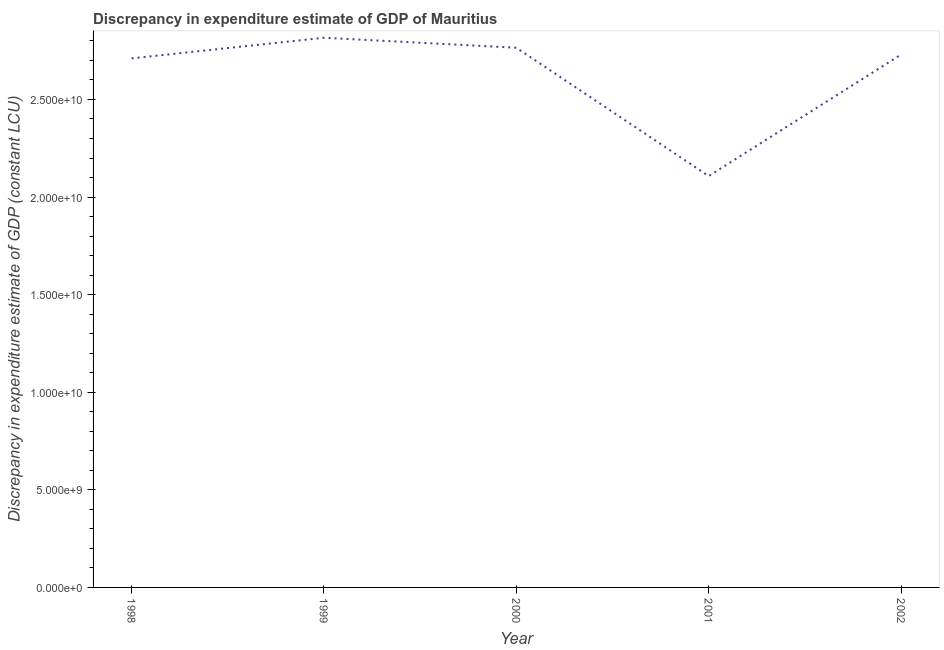What is the discrepancy in expenditure estimate of gdp in 1998?
Ensure brevity in your answer.  2.71e+1. Across all years, what is the maximum discrepancy in expenditure estimate of gdp?
Give a very brief answer. 2.82e+1. Across all years, what is the minimum discrepancy in expenditure estimate of gdp?
Offer a very short reply. 2.11e+1. In which year was the discrepancy in expenditure estimate of gdp maximum?
Your answer should be very brief. 1999. In which year was the discrepancy in expenditure estimate of gdp minimum?
Keep it short and to the point. 2001. What is the sum of the discrepancy in expenditure estimate of gdp?
Offer a terse response. 1.31e+11. What is the difference between the discrepancy in expenditure estimate of gdp in 1998 and 1999?
Ensure brevity in your answer.  -1.06e+09. What is the average discrepancy in expenditure estimate of gdp per year?
Ensure brevity in your answer.  2.63e+1. What is the median discrepancy in expenditure estimate of gdp?
Offer a terse response. 2.73e+1. In how many years, is the discrepancy in expenditure estimate of gdp greater than 12000000000 LCU?
Provide a short and direct response. 5. What is the ratio of the discrepancy in expenditure estimate of gdp in 2000 to that in 2001?
Keep it short and to the point. 1.31. Is the discrepancy in expenditure estimate of gdp in 1998 less than that in 2001?
Give a very brief answer. No. What is the difference between the highest and the second highest discrepancy in expenditure estimate of gdp?
Make the answer very short. 5.12e+08. Is the sum of the discrepancy in expenditure estimate of gdp in 1999 and 2002 greater than the maximum discrepancy in expenditure estimate of gdp across all years?
Offer a terse response. Yes. What is the difference between the highest and the lowest discrepancy in expenditure estimate of gdp?
Offer a terse response. 7.09e+09. How many lines are there?
Keep it short and to the point. 1. What is the difference between two consecutive major ticks on the Y-axis?
Your answer should be compact. 5.00e+09. Are the values on the major ticks of Y-axis written in scientific E-notation?
Provide a short and direct response. Yes. What is the title of the graph?
Provide a short and direct response. Discrepancy in expenditure estimate of GDP of Mauritius. What is the label or title of the Y-axis?
Your answer should be compact. Discrepancy in expenditure estimate of GDP (constant LCU). What is the Discrepancy in expenditure estimate of GDP (constant LCU) of 1998?
Provide a succinct answer. 2.71e+1. What is the Discrepancy in expenditure estimate of GDP (constant LCU) in 1999?
Offer a terse response. 2.82e+1. What is the Discrepancy in expenditure estimate of GDP (constant LCU) of 2000?
Ensure brevity in your answer.  2.76e+1. What is the Discrepancy in expenditure estimate of GDP (constant LCU) in 2001?
Your response must be concise. 2.11e+1. What is the Discrepancy in expenditure estimate of GDP (constant LCU) of 2002?
Provide a succinct answer. 2.73e+1. What is the difference between the Discrepancy in expenditure estimate of GDP (constant LCU) in 1998 and 1999?
Provide a short and direct response. -1.06e+09. What is the difference between the Discrepancy in expenditure estimate of GDP (constant LCU) in 1998 and 2000?
Make the answer very short. -5.45e+08. What is the difference between the Discrepancy in expenditure estimate of GDP (constant LCU) in 1998 and 2001?
Keep it short and to the point. 6.03e+09. What is the difference between the Discrepancy in expenditure estimate of GDP (constant LCU) in 1998 and 2002?
Make the answer very short. -1.94e+08. What is the difference between the Discrepancy in expenditure estimate of GDP (constant LCU) in 1999 and 2000?
Keep it short and to the point. 5.12e+08. What is the difference between the Discrepancy in expenditure estimate of GDP (constant LCU) in 1999 and 2001?
Your answer should be compact. 7.09e+09. What is the difference between the Discrepancy in expenditure estimate of GDP (constant LCU) in 1999 and 2002?
Make the answer very short. 8.63e+08. What is the difference between the Discrepancy in expenditure estimate of GDP (constant LCU) in 2000 and 2001?
Your answer should be very brief. 6.57e+09. What is the difference between the Discrepancy in expenditure estimate of GDP (constant LCU) in 2000 and 2002?
Offer a terse response. 3.50e+08. What is the difference between the Discrepancy in expenditure estimate of GDP (constant LCU) in 2001 and 2002?
Provide a succinct answer. -6.22e+09. What is the ratio of the Discrepancy in expenditure estimate of GDP (constant LCU) in 1998 to that in 2000?
Ensure brevity in your answer.  0.98. What is the ratio of the Discrepancy in expenditure estimate of GDP (constant LCU) in 1998 to that in 2001?
Make the answer very short. 1.29. What is the ratio of the Discrepancy in expenditure estimate of GDP (constant LCU) in 1999 to that in 2000?
Provide a succinct answer. 1.02. What is the ratio of the Discrepancy in expenditure estimate of GDP (constant LCU) in 1999 to that in 2001?
Offer a very short reply. 1.34. What is the ratio of the Discrepancy in expenditure estimate of GDP (constant LCU) in 1999 to that in 2002?
Offer a very short reply. 1.03. What is the ratio of the Discrepancy in expenditure estimate of GDP (constant LCU) in 2000 to that in 2001?
Provide a succinct answer. 1.31. What is the ratio of the Discrepancy in expenditure estimate of GDP (constant LCU) in 2000 to that in 2002?
Offer a terse response. 1.01. What is the ratio of the Discrepancy in expenditure estimate of GDP (constant LCU) in 2001 to that in 2002?
Offer a very short reply. 0.77. 